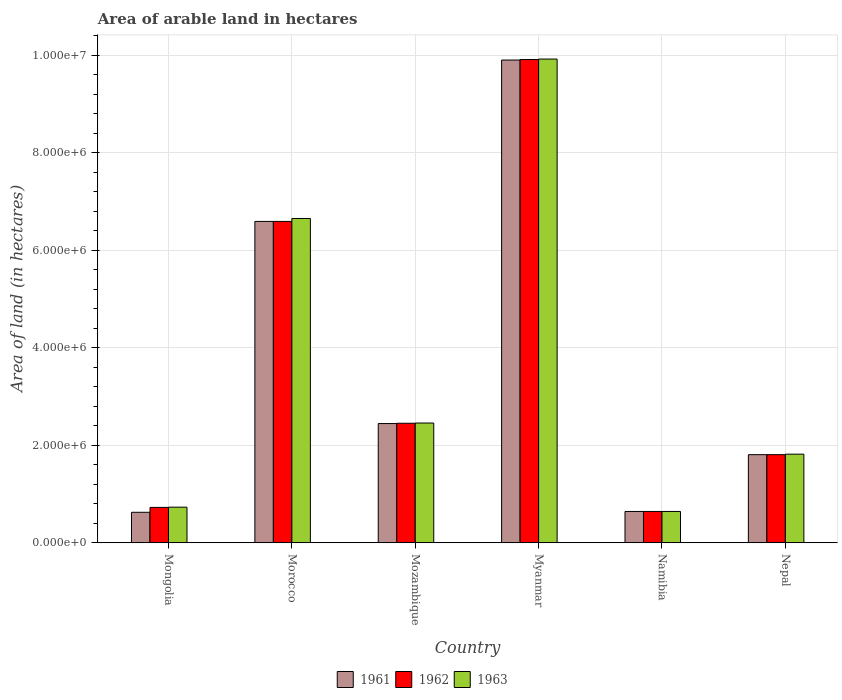How many different coloured bars are there?
Give a very brief answer. 3. How many groups of bars are there?
Give a very brief answer. 6. Are the number of bars per tick equal to the number of legend labels?
Ensure brevity in your answer.  Yes. Are the number of bars on each tick of the X-axis equal?
Offer a terse response. Yes. How many bars are there on the 6th tick from the right?
Give a very brief answer. 3. What is the label of the 6th group of bars from the left?
Offer a terse response. Nepal. What is the total arable land in 1961 in Mongolia?
Provide a succinct answer. 6.24e+05. Across all countries, what is the maximum total arable land in 1962?
Your answer should be compact. 9.91e+06. Across all countries, what is the minimum total arable land in 1962?
Ensure brevity in your answer.  6.41e+05. In which country was the total arable land in 1962 maximum?
Offer a very short reply. Myanmar. In which country was the total arable land in 1961 minimum?
Make the answer very short. Mongolia. What is the total total arable land in 1962 in the graph?
Your answer should be very brief. 2.21e+07. What is the difference between the total arable land in 1963 in Mongolia and that in Myanmar?
Offer a terse response. -9.19e+06. What is the difference between the total arable land in 1961 in Myanmar and the total arable land in 1962 in Namibia?
Provide a succinct answer. 9.26e+06. What is the average total arable land in 1963 per country?
Your answer should be compact. 3.70e+06. What is the difference between the total arable land of/in 1962 and total arable land of/in 1963 in Mongolia?
Keep it short and to the point. -5000. In how many countries, is the total arable land in 1962 greater than 8800000 hectares?
Your answer should be compact. 1. What is the ratio of the total arable land in 1962 in Mongolia to that in Namibia?
Your response must be concise. 1.13. Is the total arable land in 1963 in Morocco less than that in Nepal?
Your answer should be compact. No. Is the difference between the total arable land in 1962 in Mongolia and Myanmar greater than the difference between the total arable land in 1963 in Mongolia and Myanmar?
Offer a very short reply. Yes. What is the difference between the highest and the second highest total arable land in 1961?
Ensure brevity in your answer.  3.31e+06. What is the difference between the highest and the lowest total arable land in 1961?
Provide a short and direct response. 9.28e+06. What does the 3rd bar from the left in Nepal represents?
Provide a succinct answer. 1963. Are all the bars in the graph horizontal?
Give a very brief answer. No. How many countries are there in the graph?
Your answer should be very brief. 6. Where does the legend appear in the graph?
Your response must be concise. Bottom center. How many legend labels are there?
Give a very brief answer. 3. What is the title of the graph?
Provide a short and direct response. Area of arable land in hectares. Does "1986" appear as one of the legend labels in the graph?
Keep it short and to the point. No. What is the label or title of the X-axis?
Keep it short and to the point. Country. What is the label or title of the Y-axis?
Your response must be concise. Area of land (in hectares). What is the Area of land (in hectares) in 1961 in Mongolia?
Provide a short and direct response. 6.24e+05. What is the Area of land (in hectares) in 1962 in Mongolia?
Your response must be concise. 7.24e+05. What is the Area of land (in hectares) in 1963 in Mongolia?
Ensure brevity in your answer.  7.29e+05. What is the Area of land (in hectares) of 1961 in Morocco?
Your response must be concise. 6.59e+06. What is the Area of land (in hectares) of 1962 in Morocco?
Your answer should be compact. 6.59e+06. What is the Area of land (in hectares) in 1963 in Morocco?
Ensure brevity in your answer.  6.65e+06. What is the Area of land (in hectares) in 1961 in Mozambique?
Give a very brief answer. 2.44e+06. What is the Area of land (in hectares) of 1962 in Mozambique?
Provide a short and direct response. 2.45e+06. What is the Area of land (in hectares) of 1963 in Mozambique?
Provide a short and direct response. 2.46e+06. What is the Area of land (in hectares) of 1961 in Myanmar?
Offer a very short reply. 9.90e+06. What is the Area of land (in hectares) of 1962 in Myanmar?
Your response must be concise. 9.91e+06. What is the Area of land (in hectares) in 1963 in Myanmar?
Offer a very short reply. 9.92e+06. What is the Area of land (in hectares) of 1961 in Namibia?
Offer a terse response. 6.41e+05. What is the Area of land (in hectares) in 1962 in Namibia?
Ensure brevity in your answer.  6.41e+05. What is the Area of land (in hectares) in 1963 in Namibia?
Provide a short and direct response. 6.41e+05. What is the Area of land (in hectares) in 1961 in Nepal?
Offer a terse response. 1.81e+06. What is the Area of land (in hectares) in 1962 in Nepal?
Provide a short and direct response. 1.81e+06. What is the Area of land (in hectares) of 1963 in Nepal?
Provide a succinct answer. 1.82e+06. Across all countries, what is the maximum Area of land (in hectares) of 1961?
Give a very brief answer. 9.90e+06. Across all countries, what is the maximum Area of land (in hectares) of 1962?
Make the answer very short. 9.91e+06. Across all countries, what is the maximum Area of land (in hectares) of 1963?
Make the answer very short. 9.92e+06. Across all countries, what is the minimum Area of land (in hectares) of 1961?
Make the answer very short. 6.24e+05. Across all countries, what is the minimum Area of land (in hectares) of 1962?
Your response must be concise. 6.41e+05. Across all countries, what is the minimum Area of land (in hectares) in 1963?
Offer a terse response. 6.41e+05. What is the total Area of land (in hectares) of 1961 in the graph?
Your answer should be very brief. 2.20e+07. What is the total Area of land (in hectares) of 1962 in the graph?
Offer a terse response. 2.21e+07. What is the total Area of land (in hectares) of 1963 in the graph?
Offer a terse response. 2.22e+07. What is the difference between the Area of land (in hectares) of 1961 in Mongolia and that in Morocco?
Your answer should be very brief. -5.97e+06. What is the difference between the Area of land (in hectares) in 1962 in Mongolia and that in Morocco?
Give a very brief answer. -5.87e+06. What is the difference between the Area of land (in hectares) in 1963 in Mongolia and that in Morocco?
Your answer should be very brief. -5.92e+06. What is the difference between the Area of land (in hectares) of 1961 in Mongolia and that in Mozambique?
Provide a succinct answer. -1.82e+06. What is the difference between the Area of land (in hectares) of 1962 in Mongolia and that in Mozambique?
Keep it short and to the point. -1.73e+06. What is the difference between the Area of land (in hectares) of 1963 in Mongolia and that in Mozambique?
Your response must be concise. -1.73e+06. What is the difference between the Area of land (in hectares) in 1961 in Mongolia and that in Myanmar?
Your answer should be very brief. -9.28e+06. What is the difference between the Area of land (in hectares) of 1962 in Mongolia and that in Myanmar?
Give a very brief answer. -9.19e+06. What is the difference between the Area of land (in hectares) of 1963 in Mongolia and that in Myanmar?
Keep it short and to the point. -9.19e+06. What is the difference between the Area of land (in hectares) in 1961 in Mongolia and that in Namibia?
Ensure brevity in your answer.  -1.70e+04. What is the difference between the Area of land (in hectares) of 1962 in Mongolia and that in Namibia?
Your response must be concise. 8.30e+04. What is the difference between the Area of land (in hectares) in 1963 in Mongolia and that in Namibia?
Ensure brevity in your answer.  8.80e+04. What is the difference between the Area of land (in hectares) in 1961 in Mongolia and that in Nepal?
Your answer should be compact. -1.18e+06. What is the difference between the Area of land (in hectares) in 1962 in Mongolia and that in Nepal?
Your answer should be very brief. -1.08e+06. What is the difference between the Area of land (in hectares) in 1963 in Mongolia and that in Nepal?
Make the answer very short. -1.09e+06. What is the difference between the Area of land (in hectares) of 1961 in Morocco and that in Mozambique?
Your answer should be very brief. 4.15e+06. What is the difference between the Area of land (in hectares) in 1962 in Morocco and that in Mozambique?
Your answer should be compact. 4.14e+06. What is the difference between the Area of land (in hectares) in 1963 in Morocco and that in Mozambique?
Provide a short and direct response. 4.20e+06. What is the difference between the Area of land (in hectares) in 1961 in Morocco and that in Myanmar?
Provide a succinct answer. -3.31e+06. What is the difference between the Area of land (in hectares) of 1962 in Morocco and that in Myanmar?
Offer a terse response. -3.32e+06. What is the difference between the Area of land (in hectares) in 1963 in Morocco and that in Myanmar?
Your response must be concise. -3.27e+06. What is the difference between the Area of land (in hectares) in 1961 in Morocco and that in Namibia?
Your answer should be very brief. 5.95e+06. What is the difference between the Area of land (in hectares) of 1962 in Morocco and that in Namibia?
Provide a short and direct response. 5.95e+06. What is the difference between the Area of land (in hectares) in 1963 in Morocco and that in Namibia?
Provide a succinct answer. 6.01e+06. What is the difference between the Area of land (in hectares) in 1961 in Morocco and that in Nepal?
Keep it short and to the point. 4.78e+06. What is the difference between the Area of land (in hectares) in 1962 in Morocco and that in Nepal?
Give a very brief answer. 4.78e+06. What is the difference between the Area of land (in hectares) of 1963 in Morocco and that in Nepal?
Offer a very short reply. 4.83e+06. What is the difference between the Area of land (in hectares) of 1961 in Mozambique and that in Myanmar?
Ensure brevity in your answer.  -7.46e+06. What is the difference between the Area of land (in hectares) of 1962 in Mozambique and that in Myanmar?
Keep it short and to the point. -7.46e+06. What is the difference between the Area of land (in hectares) in 1963 in Mozambique and that in Myanmar?
Provide a succinct answer. -7.46e+06. What is the difference between the Area of land (in hectares) in 1961 in Mozambique and that in Namibia?
Provide a succinct answer. 1.80e+06. What is the difference between the Area of land (in hectares) in 1962 in Mozambique and that in Namibia?
Your answer should be very brief. 1.81e+06. What is the difference between the Area of land (in hectares) in 1963 in Mozambique and that in Namibia?
Provide a short and direct response. 1.81e+06. What is the difference between the Area of land (in hectares) of 1961 in Mozambique and that in Nepal?
Your response must be concise. 6.38e+05. What is the difference between the Area of land (in hectares) in 1962 in Mozambique and that in Nepal?
Your answer should be compact. 6.44e+05. What is the difference between the Area of land (in hectares) of 1963 in Mozambique and that in Nepal?
Offer a very short reply. 6.39e+05. What is the difference between the Area of land (in hectares) of 1961 in Myanmar and that in Namibia?
Provide a short and direct response. 9.26e+06. What is the difference between the Area of land (in hectares) of 1962 in Myanmar and that in Namibia?
Provide a succinct answer. 9.27e+06. What is the difference between the Area of land (in hectares) in 1963 in Myanmar and that in Namibia?
Provide a short and direct response. 9.28e+06. What is the difference between the Area of land (in hectares) in 1961 in Myanmar and that in Nepal?
Offer a very short reply. 8.09e+06. What is the difference between the Area of land (in hectares) in 1962 in Myanmar and that in Nepal?
Provide a succinct answer. 8.10e+06. What is the difference between the Area of land (in hectares) of 1963 in Myanmar and that in Nepal?
Offer a very short reply. 8.10e+06. What is the difference between the Area of land (in hectares) of 1961 in Namibia and that in Nepal?
Your answer should be very brief. -1.16e+06. What is the difference between the Area of land (in hectares) of 1962 in Namibia and that in Nepal?
Provide a short and direct response. -1.16e+06. What is the difference between the Area of land (in hectares) in 1963 in Namibia and that in Nepal?
Your response must be concise. -1.18e+06. What is the difference between the Area of land (in hectares) in 1961 in Mongolia and the Area of land (in hectares) in 1962 in Morocco?
Provide a short and direct response. -5.97e+06. What is the difference between the Area of land (in hectares) in 1961 in Mongolia and the Area of land (in hectares) in 1963 in Morocco?
Keep it short and to the point. -6.03e+06. What is the difference between the Area of land (in hectares) of 1962 in Mongolia and the Area of land (in hectares) of 1963 in Morocco?
Offer a very short reply. -5.93e+06. What is the difference between the Area of land (in hectares) of 1961 in Mongolia and the Area of land (in hectares) of 1962 in Mozambique?
Give a very brief answer. -1.83e+06. What is the difference between the Area of land (in hectares) in 1961 in Mongolia and the Area of land (in hectares) in 1963 in Mozambique?
Make the answer very short. -1.83e+06. What is the difference between the Area of land (in hectares) in 1962 in Mongolia and the Area of land (in hectares) in 1963 in Mozambique?
Offer a very short reply. -1.73e+06. What is the difference between the Area of land (in hectares) of 1961 in Mongolia and the Area of land (in hectares) of 1962 in Myanmar?
Your answer should be very brief. -9.29e+06. What is the difference between the Area of land (in hectares) of 1961 in Mongolia and the Area of land (in hectares) of 1963 in Myanmar?
Make the answer very short. -9.30e+06. What is the difference between the Area of land (in hectares) of 1962 in Mongolia and the Area of land (in hectares) of 1963 in Myanmar?
Your answer should be compact. -9.20e+06. What is the difference between the Area of land (in hectares) of 1961 in Mongolia and the Area of land (in hectares) of 1962 in Namibia?
Offer a very short reply. -1.70e+04. What is the difference between the Area of land (in hectares) of 1961 in Mongolia and the Area of land (in hectares) of 1963 in Namibia?
Keep it short and to the point. -1.70e+04. What is the difference between the Area of land (in hectares) in 1962 in Mongolia and the Area of land (in hectares) in 1963 in Namibia?
Keep it short and to the point. 8.30e+04. What is the difference between the Area of land (in hectares) of 1961 in Mongolia and the Area of land (in hectares) of 1962 in Nepal?
Your response must be concise. -1.18e+06. What is the difference between the Area of land (in hectares) of 1961 in Mongolia and the Area of land (in hectares) of 1963 in Nepal?
Your answer should be compact. -1.19e+06. What is the difference between the Area of land (in hectares) of 1962 in Mongolia and the Area of land (in hectares) of 1963 in Nepal?
Your answer should be very brief. -1.09e+06. What is the difference between the Area of land (in hectares) in 1961 in Morocco and the Area of land (in hectares) in 1962 in Mozambique?
Ensure brevity in your answer.  4.14e+06. What is the difference between the Area of land (in hectares) of 1961 in Morocco and the Area of land (in hectares) of 1963 in Mozambique?
Make the answer very short. 4.14e+06. What is the difference between the Area of land (in hectares) of 1962 in Morocco and the Area of land (in hectares) of 1963 in Mozambique?
Make the answer very short. 4.14e+06. What is the difference between the Area of land (in hectares) of 1961 in Morocco and the Area of land (in hectares) of 1962 in Myanmar?
Your response must be concise. -3.32e+06. What is the difference between the Area of land (in hectares) in 1961 in Morocco and the Area of land (in hectares) in 1963 in Myanmar?
Your answer should be compact. -3.33e+06. What is the difference between the Area of land (in hectares) in 1962 in Morocco and the Area of land (in hectares) in 1963 in Myanmar?
Provide a short and direct response. -3.33e+06. What is the difference between the Area of land (in hectares) of 1961 in Morocco and the Area of land (in hectares) of 1962 in Namibia?
Your answer should be compact. 5.95e+06. What is the difference between the Area of land (in hectares) of 1961 in Morocco and the Area of land (in hectares) of 1963 in Namibia?
Make the answer very short. 5.95e+06. What is the difference between the Area of land (in hectares) in 1962 in Morocco and the Area of land (in hectares) in 1963 in Namibia?
Offer a terse response. 5.95e+06. What is the difference between the Area of land (in hectares) in 1961 in Morocco and the Area of land (in hectares) in 1962 in Nepal?
Provide a succinct answer. 4.78e+06. What is the difference between the Area of land (in hectares) of 1961 in Morocco and the Area of land (in hectares) of 1963 in Nepal?
Provide a short and direct response. 4.77e+06. What is the difference between the Area of land (in hectares) in 1962 in Morocco and the Area of land (in hectares) in 1963 in Nepal?
Give a very brief answer. 4.77e+06. What is the difference between the Area of land (in hectares) in 1961 in Mozambique and the Area of land (in hectares) in 1962 in Myanmar?
Your answer should be compact. -7.47e+06. What is the difference between the Area of land (in hectares) in 1961 in Mozambique and the Area of land (in hectares) in 1963 in Myanmar?
Provide a succinct answer. -7.48e+06. What is the difference between the Area of land (in hectares) in 1962 in Mozambique and the Area of land (in hectares) in 1963 in Myanmar?
Provide a short and direct response. -7.47e+06. What is the difference between the Area of land (in hectares) in 1961 in Mozambique and the Area of land (in hectares) in 1962 in Namibia?
Give a very brief answer. 1.80e+06. What is the difference between the Area of land (in hectares) of 1961 in Mozambique and the Area of land (in hectares) of 1963 in Namibia?
Give a very brief answer. 1.80e+06. What is the difference between the Area of land (in hectares) in 1962 in Mozambique and the Area of land (in hectares) in 1963 in Namibia?
Make the answer very short. 1.81e+06. What is the difference between the Area of land (in hectares) of 1961 in Mozambique and the Area of land (in hectares) of 1962 in Nepal?
Provide a short and direct response. 6.38e+05. What is the difference between the Area of land (in hectares) in 1961 in Mozambique and the Area of land (in hectares) in 1963 in Nepal?
Ensure brevity in your answer.  6.28e+05. What is the difference between the Area of land (in hectares) in 1962 in Mozambique and the Area of land (in hectares) in 1963 in Nepal?
Ensure brevity in your answer.  6.34e+05. What is the difference between the Area of land (in hectares) in 1961 in Myanmar and the Area of land (in hectares) in 1962 in Namibia?
Keep it short and to the point. 9.26e+06. What is the difference between the Area of land (in hectares) of 1961 in Myanmar and the Area of land (in hectares) of 1963 in Namibia?
Provide a succinct answer. 9.26e+06. What is the difference between the Area of land (in hectares) in 1962 in Myanmar and the Area of land (in hectares) in 1963 in Namibia?
Your response must be concise. 9.27e+06. What is the difference between the Area of land (in hectares) of 1961 in Myanmar and the Area of land (in hectares) of 1962 in Nepal?
Ensure brevity in your answer.  8.09e+06. What is the difference between the Area of land (in hectares) of 1961 in Myanmar and the Area of land (in hectares) of 1963 in Nepal?
Ensure brevity in your answer.  8.08e+06. What is the difference between the Area of land (in hectares) of 1962 in Myanmar and the Area of land (in hectares) of 1963 in Nepal?
Your response must be concise. 8.09e+06. What is the difference between the Area of land (in hectares) of 1961 in Namibia and the Area of land (in hectares) of 1962 in Nepal?
Provide a succinct answer. -1.16e+06. What is the difference between the Area of land (in hectares) in 1961 in Namibia and the Area of land (in hectares) in 1963 in Nepal?
Make the answer very short. -1.18e+06. What is the difference between the Area of land (in hectares) in 1962 in Namibia and the Area of land (in hectares) in 1963 in Nepal?
Provide a succinct answer. -1.18e+06. What is the average Area of land (in hectares) in 1961 per country?
Provide a short and direct response. 3.67e+06. What is the average Area of land (in hectares) of 1962 per country?
Ensure brevity in your answer.  3.69e+06. What is the average Area of land (in hectares) of 1963 per country?
Your response must be concise. 3.70e+06. What is the difference between the Area of land (in hectares) in 1961 and Area of land (in hectares) in 1963 in Mongolia?
Your response must be concise. -1.05e+05. What is the difference between the Area of land (in hectares) in 1962 and Area of land (in hectares) in 1963 in Mongolia?
Offer a very short reply. -5000. What is the difference between the Area of land (in hectares) of 1961 and Area of land (in hectares) of 1963 in Morocco?
Your answer should be very brief. -6.00e+04. What is the difference between the Area of land (in hectares) in 1962 and Area of land (in hectares) in 1963 in Morocco?
Ensure brevity in your answer.  -6.00e+04. What is the difference between the Area of land (in hectares) of 1961 and Area of land (in hectares) of 1962 in Mozambique?
Your answer should be compact. -6000. What is the difference between the Area of land (in hectares) in 1961 and Area of land (in hectares) in 1963 in Mozambique?
Provide a succinct answer. -1.10e+04. What is the difference between the Area of land (in hectares) in 1962 and Area of land (in hectares) in 1963 in Mozambique?
Offer a terse response. -5000. What is the difference between the Area of land (in hectares) in 1961 and Area of land (in hectares) in 1963 in Myanmar?
Give a very brief answer. -2.00e+04. What is the difference between the Area of land (in hectares) of 1961 and Area of land (in hectares) of 1962 in Namibia?
Provide a short and direct response. 0. What is the difference between the Area of land (in hectares) in 1961 and Area of land (in hectares) in 1963 in Namibia?
Offer a terse response. 0. What is the difference between the Area of land (in hectares) of 1962 and Area of land (in hectares) of 1963 in Namibia?
Provide a short and direct response. 0. What is the ratio of the Area of land (in hectares) of 1961 in Mongolia to that in Morocco?
Give a very brief answer. 0.09. What is the ratio of the Area of land (in hectares) of 1962 in Mongolia to that in Morocco?
Your answer should be very brief. 0.11. What is the ratio of the Area of land (in hectares) of 1963 in Mongolia to that in Morocco?
Provide a succinct answer. 0.11. What is the ratio of the Area of land (in hectares) of 1961 in Mongolia to that in Mozambique?
Give a very brief answer. 0.26. What is the ratio of the Area of land (in hectares) of 1962 in Mongolia to that in Mozambique?
Provide a short and direct response. 0.3. What is the ratio of the Area of land (in hectares) in 1963 in Mongolia to that in Mozambique?
Provide a succinct answer. 0.3. What is the ratio of the Area of land (in hectares) of 1961 in Mongolia to that in Myanmar?
Give a very brief answer. 0.06. What is the ratio of the Area of land (in hectares) in 1962 in Mongolia to that in Myanmar?
Your answer should be very brief. 0.07. What is the ratio of the Area of land (in hectares) of 1963 in Mongolia to that in Myanmar?
Offer a very short reply. 0.07. What is the ratio of the Area of land (in hectares) in 1961 in Mongolia to that in Namibia?
Provide a short and direct response. 0.97. What is the ratio of the Area of land (in hectares) of 1962 in Mongolia to that in Namibia?
Provide a succinct answer. 1.13. What is the ratio of the Area of land (in hectares) of 1963 in Mongolia to that in Namibia?
Your answer should be compact. 1.14. What is the ratio of the Area of land (in hectares) in 1961 in Mongolia to that in Nepal?
Your answer should be very brief. 0.35. What is the ratio of the Area of land (in hectares) of 1962 in Mongolia to that in Nepal?
Your answer should be compact. 0.4. What is the ratio of the Area of land (in hectares) of 1963 in Mongolia to that in Nepal?
Your response must be concise. 0.4. What is the ratio of the Area of land (in hectares) in 1961 in Morocco to that in Mozambique?
Your answer should be compact. 2.7. What is the ratio of the Area of land (in hectares) in 1962 in Morocco to that in Mozambique?
Keep it short and to the point. 2.69. What is the ratio of the Area of land (in hectares) of 1963 in Morocco to that in Mozambique?
Your answer should be very brief. 2.71. What is the ratio of the Area of land (in hectares) in 1961 in Morocco to that in Myanmar?
Your answer should be compact. 0.67. What is the ratio of the Area of land (in hectares) in 1962 in Morocco to that in Myanmar?
Your answer should be very brief. 0.67. What is the ratio of the Area of land (in hectares) of 1963 in Morocco to that in Myanmar?
Provide a short and direct response. 0.67. What is the ratio of the Area of land (in hectares) in 1961 in Morocco to that in Namibia?
Ensure brevity in your answer.  10.28. What is the ratio of the Area of land (in hectares) in 1962 in Morocco to that in Namibia?
Provide a short and direct response. 10.28. What is the ratio of the Area of land (in hectares) in 1963 in Morocco to that in Namibia?
Your response must be concise. 10.37. What is the ratio of the Area of land (in hectares) of 1961 in Morocco to that in Nepal?
Your response must be concise. 3.65. What is the ratio of the Area of land (in hectares) in 1962 in Morocco to that in Nepal?
Provide a short and direct response. 3.65. What is the ratio of the Area of land (in hectares) in 1963 in Morocco to that in Nepal?
Offer a terse response. 3.66. What is the ratio of the Area of land (in hectares) in 1961 in Mozambique to that in Myanmar?
Your response must be concise. 0.25. What is the ratio of the Area of land (in hectares) of 1962 in Mozambique to that in Myanmar?
Offer a very short reply. 0.25. What is the ratio of the Area of land (in hectares) of 1963 in Mozambique to that in Myanmar?
Offer a terse response. 0.25. What is the ratio of the Area of land (in hectares) in 1961 in Mozambique to that in Namibia?
Make the answer very short. 3.81. What is the ratio of the Area of land (in hectares) of 1962 in Mozambique to that in Namibia?
Make the answer very short. 3.82. What is the ratio of the Area of land (in hectares) in 1963 in Mozambique to that in Namibia?
Give a very brief answer. 3.83. What is the ratio of the Area of land (in hectares) of 1961 in Mozambique to that in Nepal?
Ensure brevity in your answer.  1.35. What is the ratio of the Area of land (in hectares) in 1962 in Mozambique to that in Nepal?
Make the answer very short. 1.36. What is the ratio of the Area of land (in hectares) in 1963 in Mozambique to that in Nepal?
Your answer should be very brief. 1.35. What is the ratio of the Area of land (in hectares) of 1961 in Myanmar to that in Namibia?
Ensure brevity in your answer.  15.44. What is the ratio of the Area of land (in hectares) in 1962 in Myanmar to that in Namibia?
Ensure brevity in your answer.  15.46. What is the ratio of the Area of land (in hectares) in 1963 in Myanmar to that in Namibia?
Provide a short and direct response. 15.48. What is the ratio of the Area of land (in hectares) of 1961 in Myanmar to that in Nepal?
Make the answer very short. 5.48. What is the ratio of the Area of land (in hectares) of 1962 in Myanmar to that in Nepal?
Your response must be concise. 5.49. What is the ratio of the Area of land (in hectares) in 1963 in Myanmar to that in Nepal?
Your response must be concise. 5.46. What is the ratio of the Area of land (in hectares) of 1961 in Namibia to that in Nepal?
Your answer should be very brief. 0.35. What is the ratio of the Area of land (in hectares) of 1962 in Namibia to that in Nepal?
Ensure brevity in your answer.  0.35. What is the ratio of the Area of land (in hectares) in 1963 in Namibia to that in Nepal?
Make the answer very short. 0.35. What is the difference between the highest and the second highest Area of land (in hectares) of 1961?
Offer a very short reply. 3.31e+06. What is the difference between the highest and the second highest Area of land (in hectares) in 1962?
Keep it short and to the point. 3.32e+06. What is the difference between the highest and the second highest Area of land (in hectares) of 1963?
Make the answer very short. 3.27e+06. What is the difference between the highest and the lowest Area of land (in hectares) in 1961?
Ensure brevity in your answer.  9.28e+06. What is the difference between the highest and the lowest Area of land (in hectares) in 1962?
Give a very brief answer. 9.27e+06. What is the difference between the highest and the lowest Area of land (in hectares) of 1963?
Provide a succinct answer. 9.28e+06. 